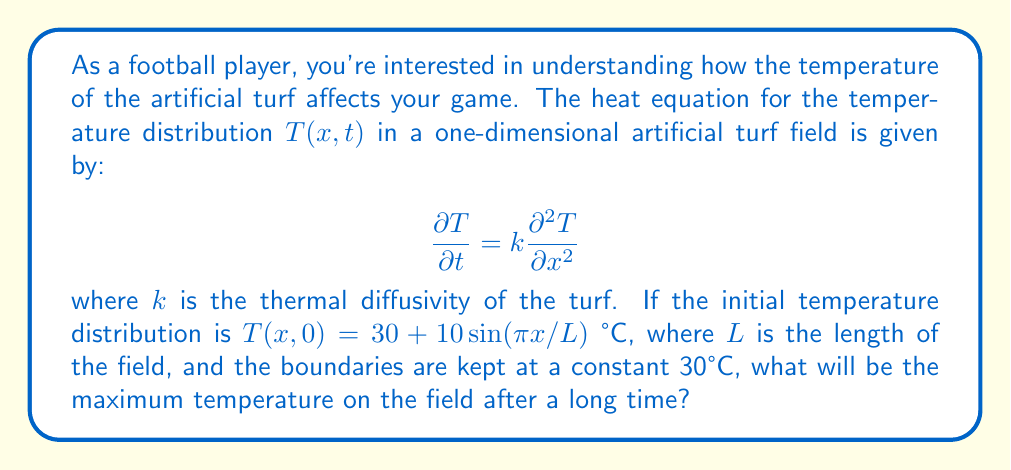Can you answer this question? Let's approach this step-by-step:

1) The heat equation given is:
   $$\frac{\partial T}{\partial t} = k\frac{\partial^2 T}{\partial x^2}$$

2) The initial condition is:
   $$T(x,0) = 30 + 10\sin(\pi x/L)$$

3) The boundary conditions are:
   $$T(0,t) = T(L,t) = 30$$

4) For long-time behavior, we look for the steady-state solution where $\frac{\partial T}{\partial t} = 0$. This reduces our equation to:

   $$0 = k\frac{\partial^2 T}{\partial x^2}$$

5) The general solution to this is:
   $$T(x) = Ax + B$$

6) Applying the boundary conditions:
   At $x=0$: $30 = B$
   At $x=L$: $30 = AL + 30$

7) This gives us $A=0$ and $B=30$

8) Therefore, the steady-state solution is:
   $$T(x) = 30$$

9) This means that after a long time, the temperature will be uniform across the field at 30°C.
Answer: 30°C 